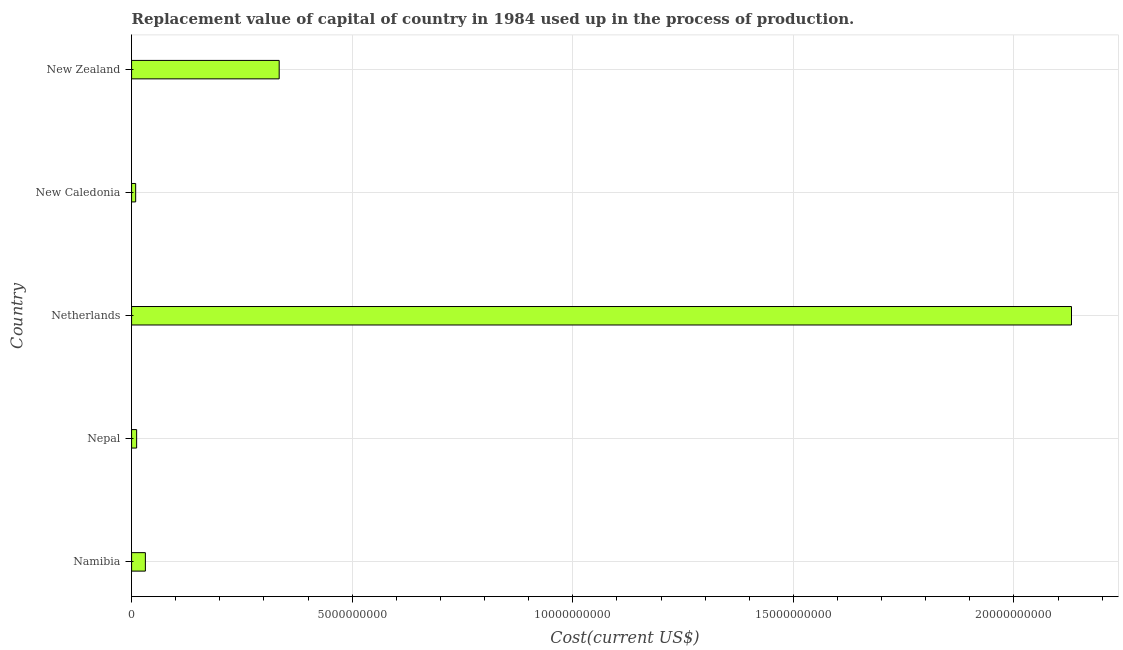Does the graph contain any zero values?
Make the answer very short. No. What is the title of the graph?
Your response must be concise. Replacement value of capital of country in 1984 used up in the process of production. What is the label or title of the X-axis?
Keep it short and to the point. Cost(current US$). What is the label or title of the Y-axis?
Offer a terse response. Country. What is the consumption of fixed capital in New Caledonia?
Provide a short and direct response. 9.28e+07. Across all countries, what is the maximum consumption of fixed capital?
Provide a succinct answer. 2.13e+1. Across all countries, what is the minimum consumption of fixed capital?
Your response must be concise. 9.28e+07. In which country was the consumption of fixed capital maximum?
Make the answer very short. Netherlands. In which country was the consumption of fixed capital minimum?
Ensure brevity in your answer.  New Caledonia. What is the sum of the consumption of fixed capital?
Your response must be concise. 2.52e+1. What is the difference between the consumption of fixed capital in Nepal and Netherlands?
Your response must be concise. -2.12e+1. What is the average consumption of fixed capital per country?
Ensure brevity in your answer.  5.03e+09. What is the median consumption of fixed capital?
Offer a terse response. 3.13e+08. What is the ratio of the consumption of fixed capital in Nepal to that in New Zealand?
Provide a succinct answer. 0.03. Is the consumption of fixed capital in Netherlands less than that in New Zealand?
Your answer should be compact. No. Is the difference between the consumption of fixed capital in New Caledonia and New Zealand greater than the difference between any two countries?
Your answer should be very brief. No. What is the difference between the highest and the second highest consumption of fixed capital?
Provide a succinct answer. 1.80e+1. What is the difference between the highest and the lowest consumption of fixed capital?
Provide a short and direct response. 2.12e+1. In how many countries, is the consumption of fixed capital greater than the average consumption of fixed capital taken over all countries?
Your answer should be very brief. 1. Are all the bars in the graph horizontal?
Your answer should be compact. Yes. How many countries are there in the graph?
Make the answer very short. 5. What is the difference between two consecutive major ticks on the X-axis?
Provide a short and direct response. 5.00e+09. Are the values on the major ticks of X-axis written in scientific E-notation?
Your answer should be compact. No. What is the Cost(current US$) of Namibia?
Your answer should be very brief. 3.13e+08. What is the Cost(current US$) in Nepal?
Provide a short and direct response. 1.15e+08. What is the Cost(current US$) of Netherlands?
Your answer should be very brief. 2.13e+1. What is the Cost(current US$) of New Caledonia?
Offer a terse response. 9.28e+07. What is the Cost(current US$) in New Zealand?
Give a very brief answer. 3.35e+09. What is the difference between the Cost(current US$) in Namibia and Nepal?
Ensure brevity in your answer.  1.98e+08. What is the difference between the Cost(current US$) in Namibia and Netherlands?
Make the answer very short. -2.10e+1. What is the difference between the Cost(current US$) in Namibia and New Caledonia?
Give a very brief answer. 2.20e+08. What is the difference between the Cost(current US$) in Namibia and New Zealand?
Your answer should be compact. -3.03e+09. What is the difference between the Cost(current US$) in Nepal and Netherlands?
Offer a terse response. -2.12e+1. What is the difference between the Cost(current US$) in Nepal and New Caledonia?
Make the answer very short. 2.17e+07. What is the difference between the Cost(current US$) in Nepal and New Zealand?
Keep it short and to the point. -3.23e+09. What is the difference between the Cost(current US$) in Netherlands and New Caledonia?
Give a very brief answer. 2.12e+1. What is the difference between the Cost(current US$) in Netherlands and New Zealand?
Ensure brevity in your answer.  1.80e+1. What is the difference between the Cost(current US$) in New Caledonia and New Zealand?
Give a very brief answer. -3.25e+09. What is the ratio of the Cost(current US$) in Namibia to that in Nepal?
Give a very brief answer. 2.73. What is the ratio of the Cost(current US$) in Namibia to that in Netherlands?
Ensure brevity in your answer.  0.01. What is the ratio of the Cost(current US$) in Namibia to that in New Caledonia?
Make the answer very short. 3.37. What is the ratio of the Cost(current US$) in Namibia to that in New Zealand?
Ensure brevity in your answer.  0.09. What is the ratio of the Cost(current US$) in Nepal to that in Netherlands?
Keep it short and to the point. 0.01. What is the ratio of the Cost(current US$) in Nepal to that in New Caledonia?
Give a very brief answer. 1.23. What is the ratio of the Cost(current US$) in Nepal to that in New Zealand?
Offer a very short reply. 0.03. What is the ratio of the Cost(current US$) in Netherlands to that in New Caledonia?
Ensure brevity in your answer.  229.56. What is the ratio of the Cost(current US$) in Netherlands to that in New Zealand?
Your response must be concise. 6.37. What is the ratio of the Cost(current US$) in New Caledonia to that in New Zealand?
Keep it short and to the point. 0.03. 